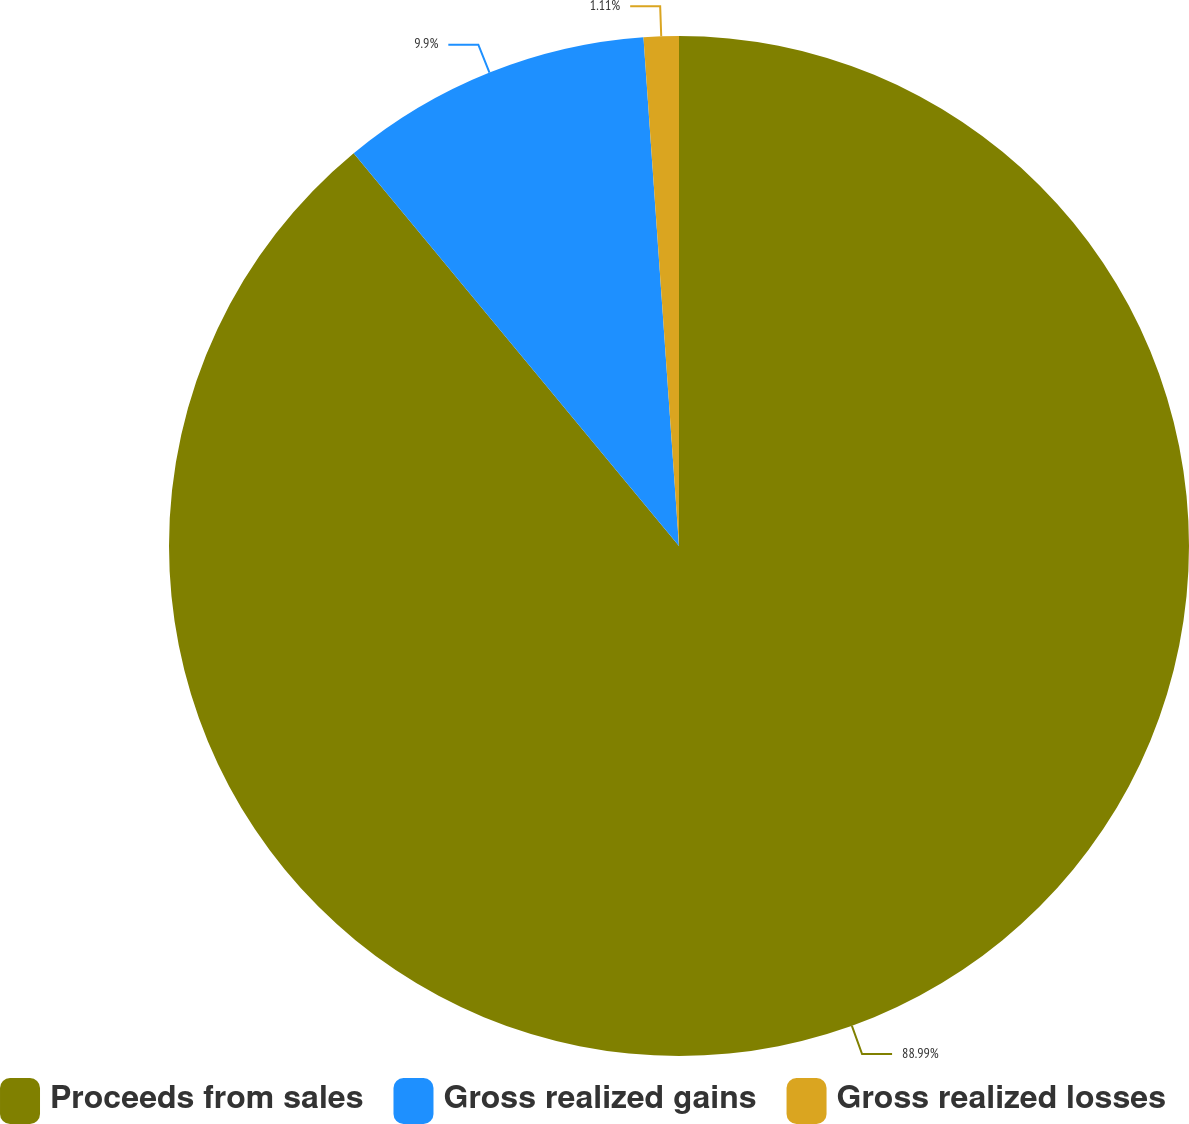<chart> <loc_0><loc_0><loc_500><loc_500><pie_chart><fcel>Proceeds from sales<fcel>Gross realized gains<fcel>Gross realized losses<nl><fcel>88.99%<fcel>9.9%<fcel>1.11%<nl></chart> 